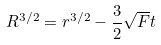Convert formula to latex. <formula><loc_0><loc_0><loc_500><loc_500>R ^ { 3 / 2 } = r ^ { 3 / 2 } - \frac { 3 } { 2 } \sqrt { F } t</formula> 